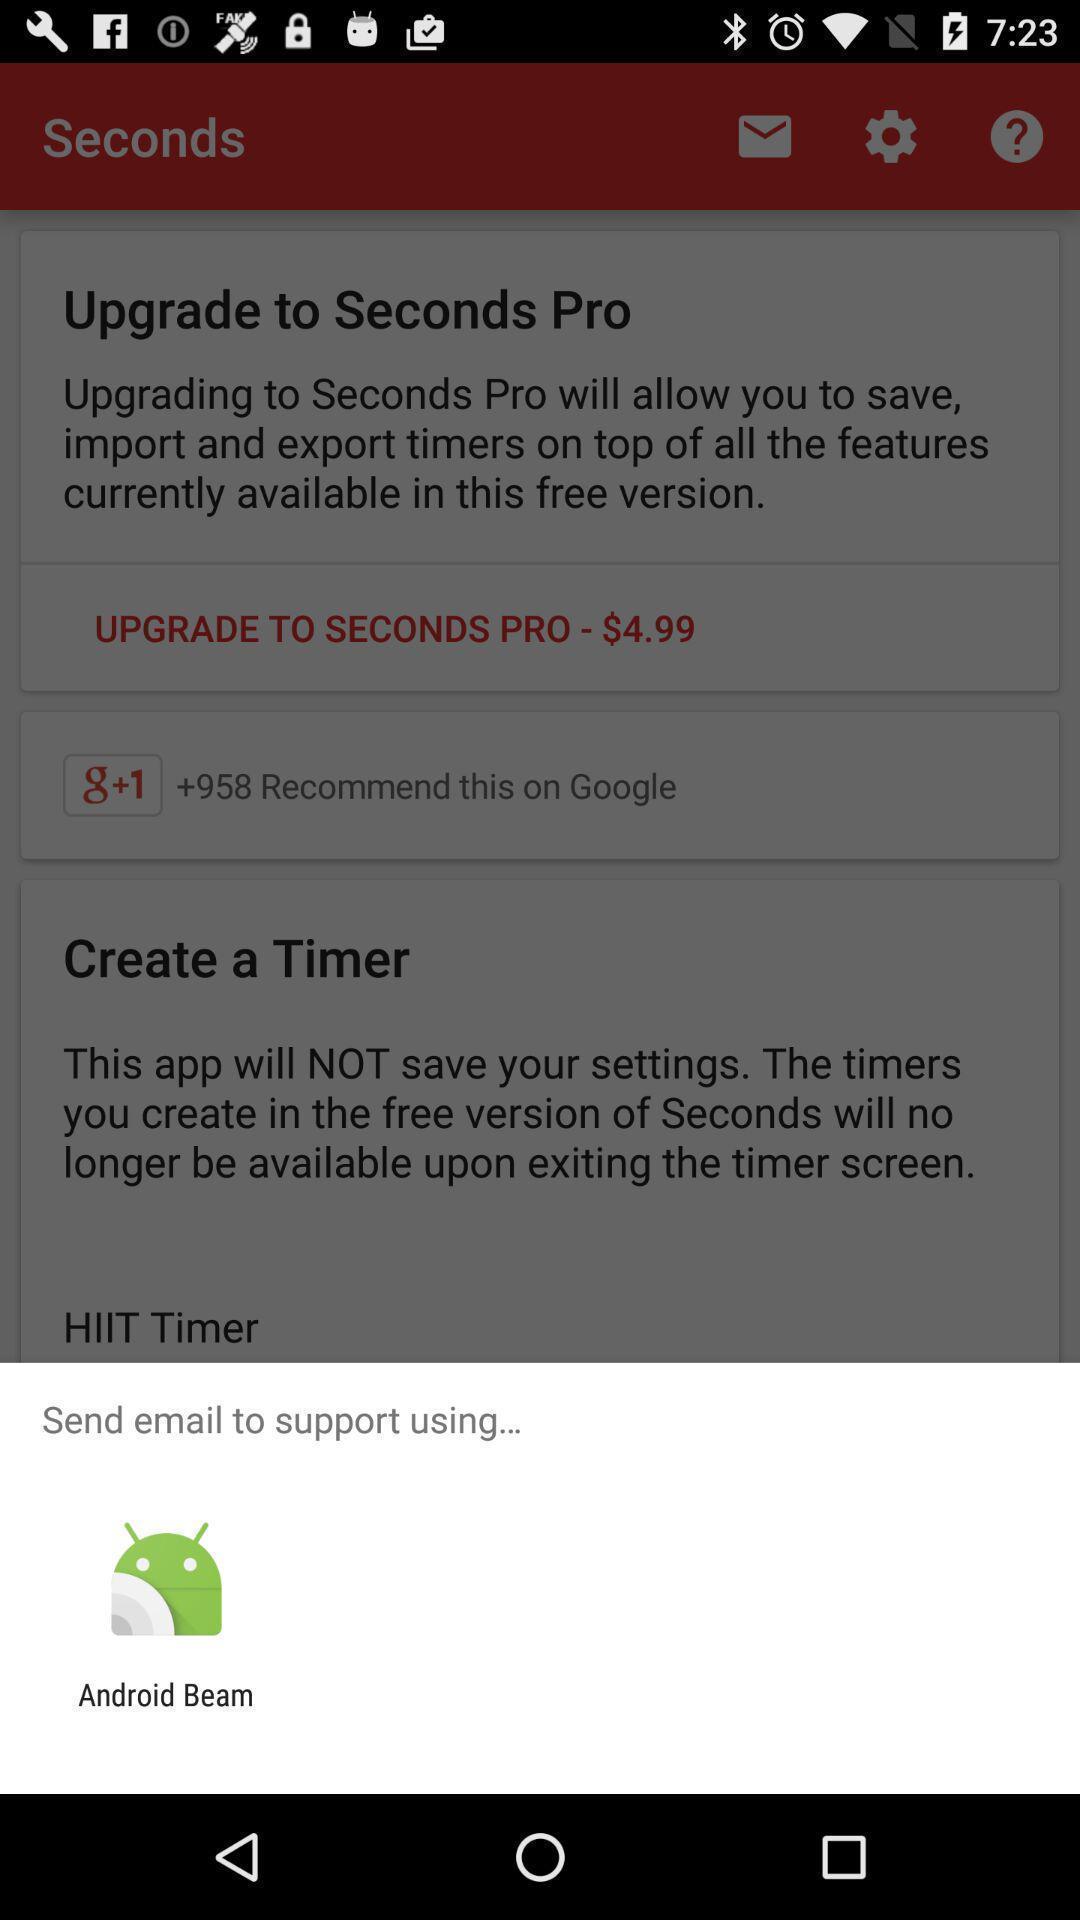Summarize the information in this screenshot. Pop-up widget showing one data sharing app. 